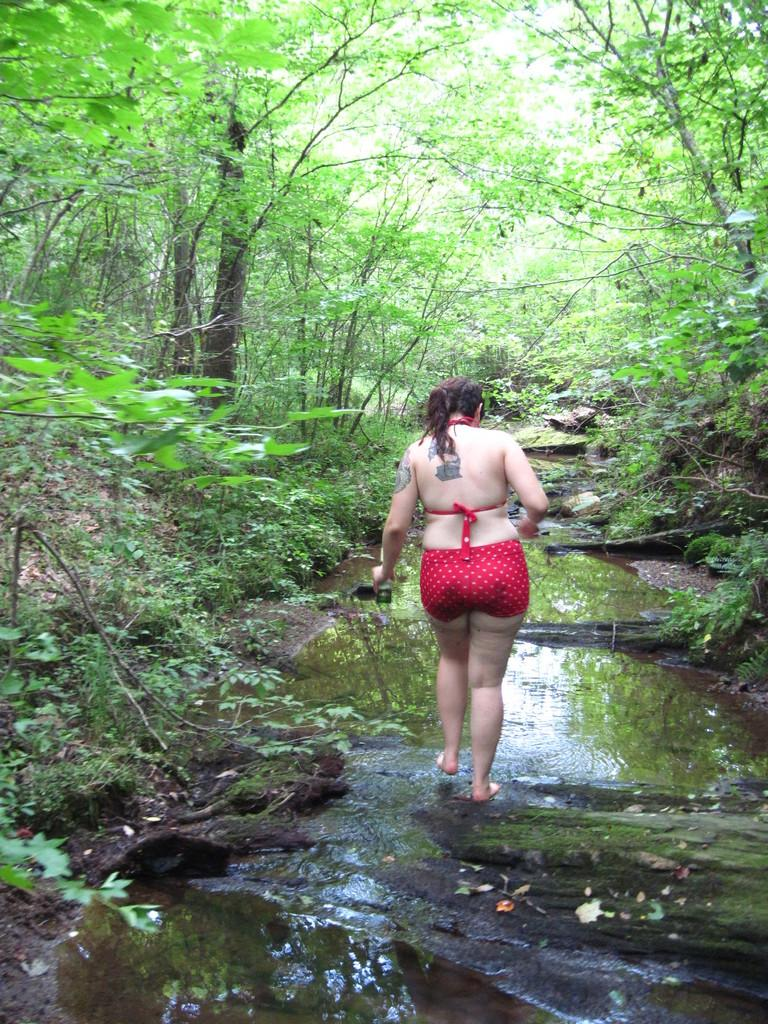What is the person in the image doing? There is a person walking in the image. On what surface is the person walking? The person is walking on the ground. What type of natural environment can be seen in the image? There are trees and water visible in the image. What type of guitar can be seen providing shade in the image? There is no guitar present in the image, and therefore no shade is being provided by a guitar. 